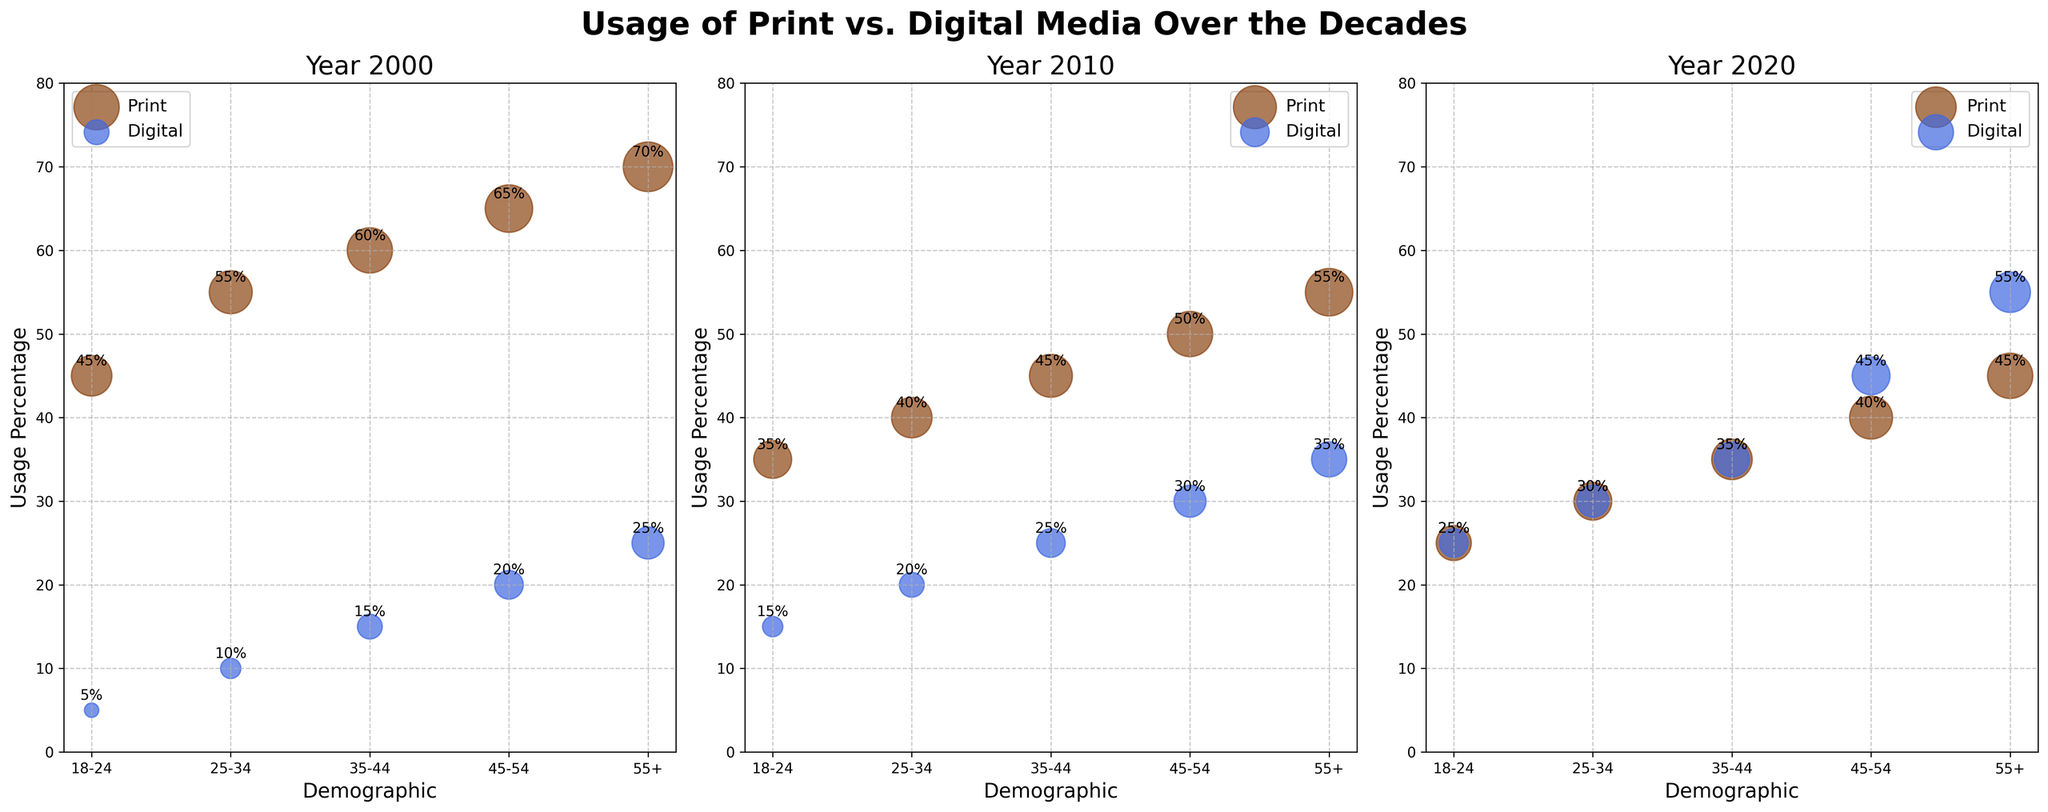Which year had the highest usage percentage of print media for the 55+ demographic? The 2000 subplot shows a usage percentage of 70% for print media in the 55+ demographic, which is higher than 55% in 2010 and 45% in 2020.
Answer: 2000 How does the usage percentage of digital media for the 18-24 demographic change across the decades? In 2000, digital media usage is 5%. It increases to 15% in 2010 and further to 25% in 2020.
Answer: It increases What is the difference in print media usage between 18-24 and 55+ demographics in the year 2010? In 2010, print media usage for 18-24 is 35%, and for 55+, it is 55%. The difference is \(55 - 35 = 20\).
Answer: 20% Comparing 2000 and 2020, which year shows a higher usage percentage of digital media for the 45-54 demographic, and by how much? In 2000, usage is 20%, and in 2020, it is 45%. The difference is \(45 - 20 = 25\). 2020 has the higher percentage.
Answer: 2020, by 25% In the 2020 subplot, which demographic shows an equal usage percentage for both print and digital media? In the 2020 subplot, the 18-24 demographic shows a 25% usage for both print and digital media.
Answer: 18-24 What is the overall trend in print media usage for the 35-44 demographic from 2000 to 2020? Print media usage decreases over time: 60% in 2000, 45% in 2010, and 35% in 2020.
Answer: Decreasing Which media type, in the year 2010, has a larger bubble size for the 25-34 demographic? In 2010, the bubble size for print media is 8, and for digital media, it is 3 for the 25-34 demographic. Print media has the larger bubble.
Answer: Print Between 2000 and 2010, how did the usage percentage of digital media for the 55+ demographic change? In 2000, digital media usage is 25% for the 55+ demographic. In 2010, it increases to 35%.
Answer: It increased by 10% 